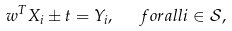<formula> <loc_0><loc_0><loc_500><loc_500>w ^ { T } X _ { i } \pm t = Y _ { i } , \ \ \ f o r a l l i \in \mathcal { S } ,</formula> 